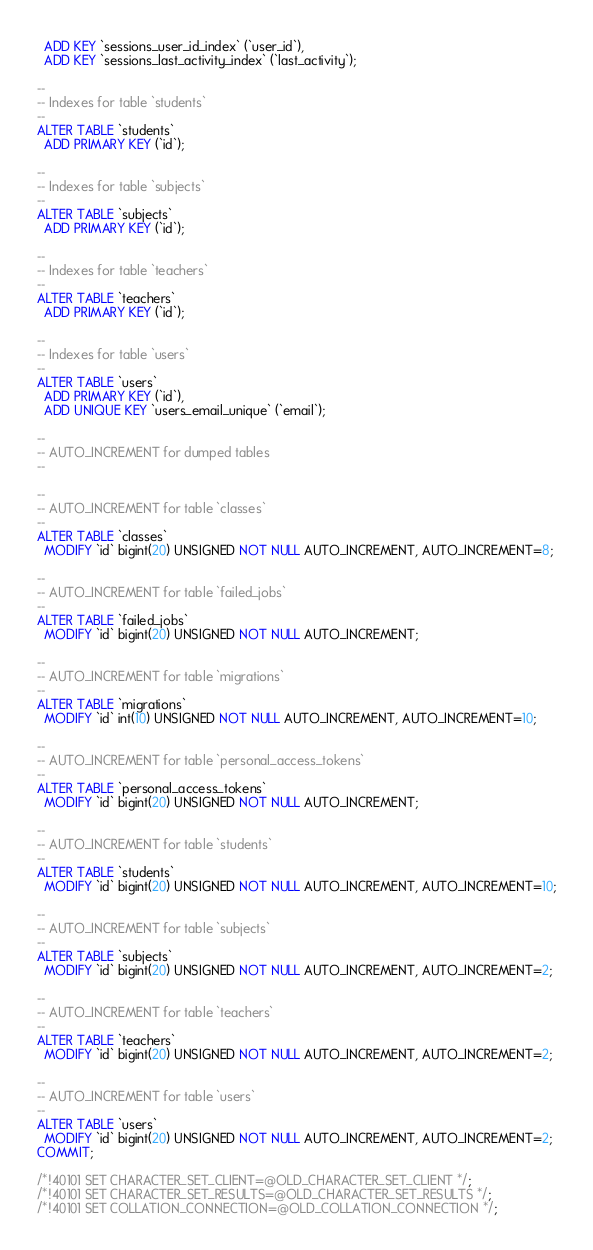Convert code to text. <code><loc_0><loc_0><loc_500><loc_500><_SQL_>  ADD KEY `sessions_user_id_index` (`user_id`),
  ADD KEY `sessions_last_activity_index` (`last_activity`);

--
-- Indexes for table `students`
--
ALTER TABLE `students`
  ADD PRIMARY KEY (`id`);

--
-- Indexes for table `subjects`
--
ALTER TABLE `subjects`
  ADD PRIMARY KEY (`id`);

--
-- Indexes for table `teachers`
--
ALTER TABLE `teachers`
  ADD PRIMARY KEY (`id`);

--
-- Indexes for table `users`
--
ALTER TABLE `users`
  ADD PRIMARY KEY (`id`),
  ADD UNIQUE KEY `users_email_unique` (`email`);

--
-- AUTO_INCREMENT for dumped tables
--

--
-- AUTO_INCREMENT for table `classes`
--
ALTER TABLE `classes`
  MODIFY `id` bigint(20) UNSIGNED NOT NULL AUTO_INCREMENT, AUTO_INCREMENT=8;

--
-- AUTO_INCREMENT for table `failed_jobs`
--
ALTER TABLE `failed_jobs`
  MODIFY `id` bigint(20) UNSIGNED NOT NULL AUTO_INCREMENT;

--
-- AUTO_INCREMENT for table `migrations`
--
ALTER TABLE `migrations`
  MODIFY `id` int(10) UNSIGNED NOT NULL AUTO_INCREMENT, AUTO_INCREMENT=10;

--
-- AUTO_INCREMENT for table `personal_access_tokens`
--
ALTER TABLE `personal_access_tokens`
  MODIFY `id` bigint(20) UNSIGNED NOT NULL AUTO_INCREMENT;

--
-- AUTO_INCREMENT for table `students`
--
ALTER TABLE `students`
  MODIFY `id` bigint(20) UNSIGNED NOT NULL AUTO_INCREMENT, AUTO_INCREMENT=10;

--
-- AUTO_INCREMENT for table `subjects`
--
ALTER TABLE `subjects`
  MODIFY `id` bigint(20) UNSIGNED NOT NULL AUTO_INCREMENT, AUTO_INCREMENT=2;

--
-- AUTO_INCREMENT for table `teachers`
--
ALTER TABLE `teachers`
  MODIFY `id` bigint(20) UNSIGNED NOT NULL AUTO_INCREMENT, AUTO_INCREMENT=2;

--
-- AUTO_INCREMENT for table `users`
--
ALTER TABLE `users`
  MODIFY `id` bigint(20) UNSIGNED NOT NULL AUTO_INCREMENT, AUTO_INCREMENT=2;
COMMIT;

/*!40101 SET CHARACTER_SET_CLIENT=@OLD_CHARACTER_SET_CLIENT */;
/*!40101 SET CHARACTER_SET_RESULTS=@OLD_CHARACTER_SET_RESULTS */;
/*!40101 SET COLLATION_CONNECTION=@OLD_COLLATION_CONNECTION */;
</code> 